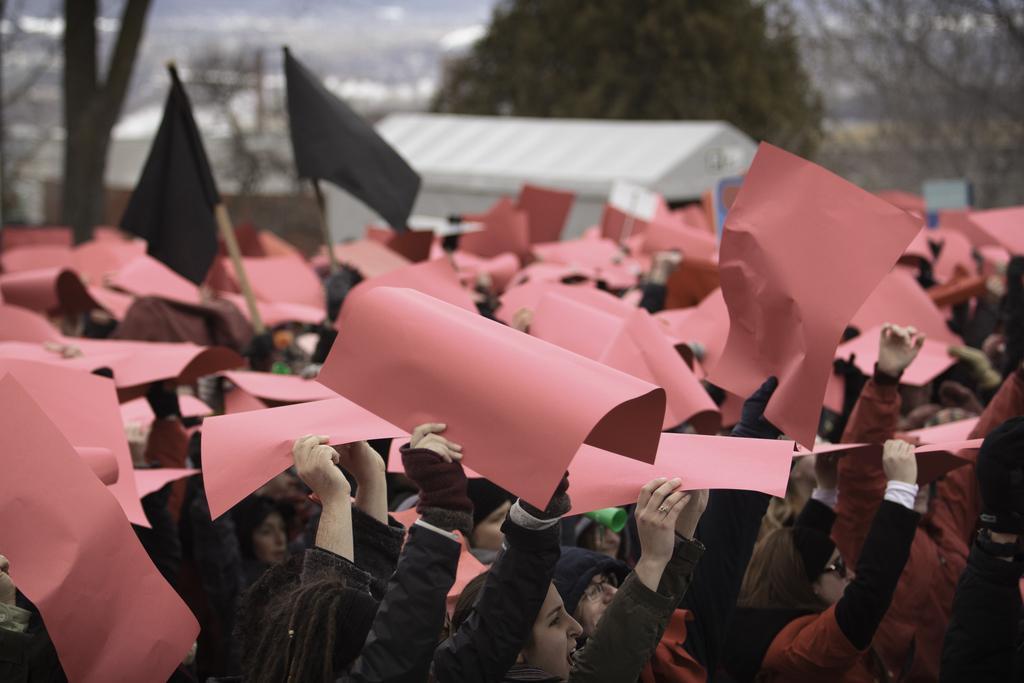Please provide a concise description of this image. At the bottom there is a group of persons who are holding paper and black flag. In the background we can see shade, trees and buildings. 